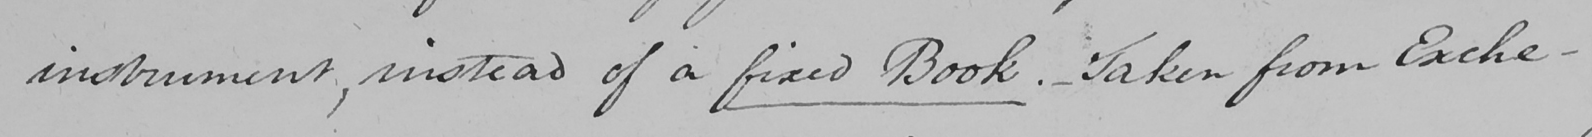What text is written in this handwritten line? instrument , instead of a fixed Book .  _  Taken from Exche- 